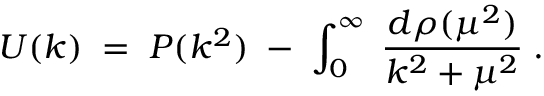<formula> <loc_0><loc_0><loc_500><loc_500>U ( k ) \, = \, P ( k ^ { 2 } ) \, - \, \int _ { 0 } ^ { \infty } \, \frac { d \rho ( \mu ^ { 2 } ) } { k ^ { 2 } + \mu ^ { 2 } } \, .</formula> 